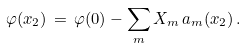<formula> <loc_0><loc_0><loc_500><loc_500>\varphi ( x _ { 2 } ) \, = \, \varphi ( 0 ) - \sum _ { m } X _ { m } \, a _ { m } ( x _ { 2 } ) \, .</formula> 